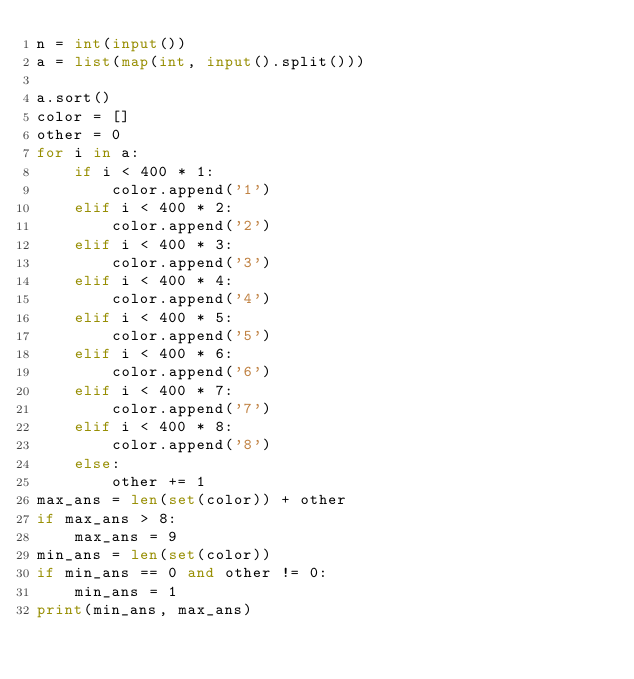<code> <loc_0><loc_0><loc_500><loc_500><_Python_>n = int(input())
a = list(map(int, input().split()))

a.sort()
color = []
other = 0
for i in a:
    if i < 400 * 1:
        color.append('1')
    elif i < 400 * 2:
        color.append('2')
    elif i < 400 * 3:
        color.append('3')
    elif i < 400 * 4:
        color.append('4')
    elif i < 400 * 5:
        color.append('5')
    elif i < 400 * 6:
        color.append('6')
    elif i < 400 * 7:
        color.append('7')
    elif i < 400 * 8:
        color.append('8')
    else:
        other += 1
max_ans = len(set(color)) + other
if max_ans > 8:
    max_ans = 9
min_ans = len(set(color))
if min_ans == 0 and other != 0:
    min_ans = 1
print(min_ans, max_ans)
</code> 